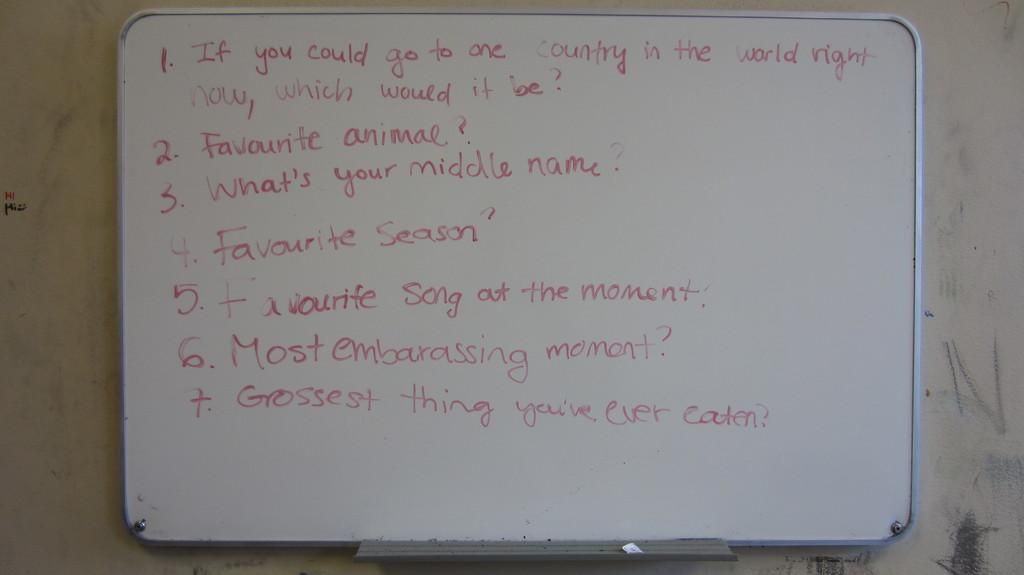<image>
Offer a succinct explanation of the picture presented. the word song is present among other words on a white board 